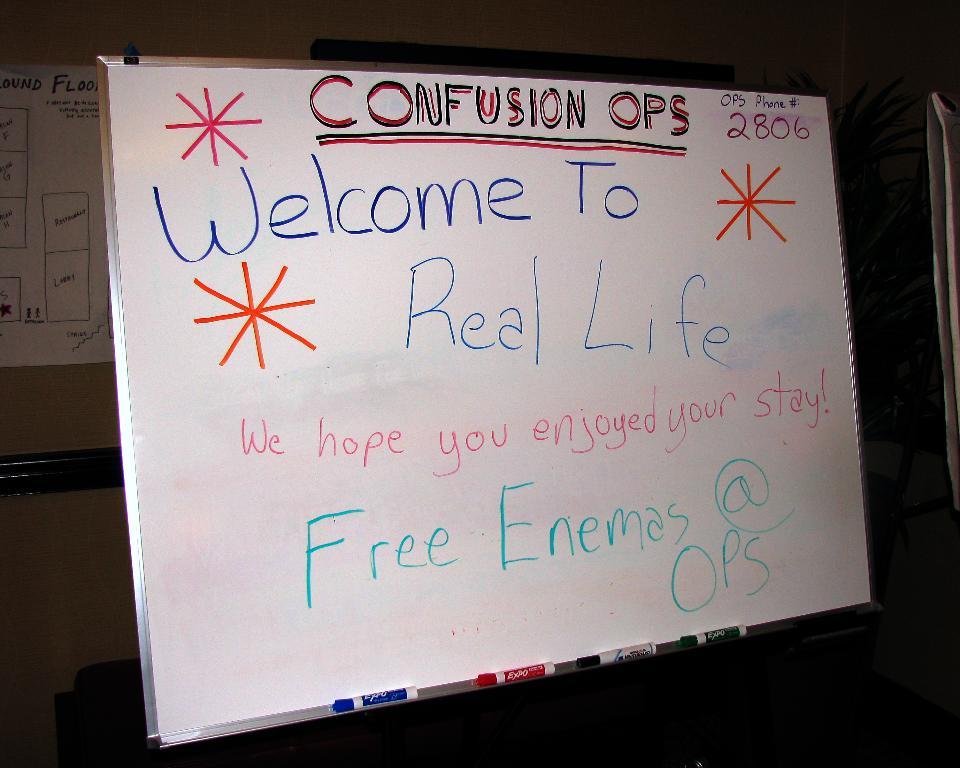What is the sign welcoming people to?
Your answer should be compact. Real life. What is free?
Your response must be concise. Enemas. 